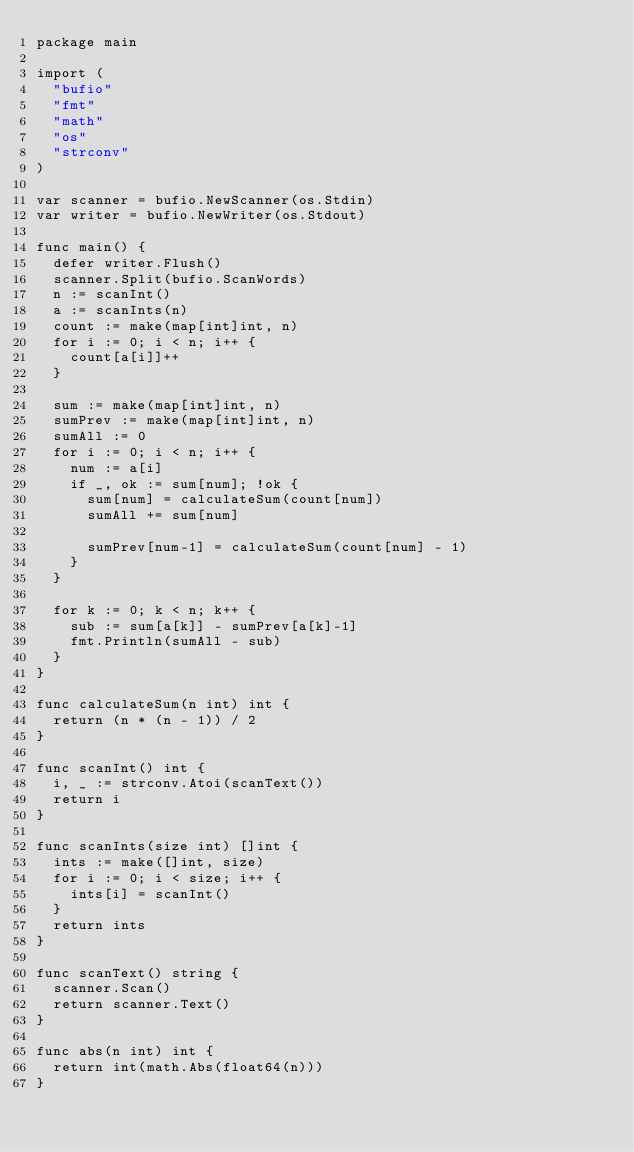<code> <loc_0><loc_0><loc_500><loc_500><_Go_>package main

import (
	"bufio"
	"fmt"
	"math"
	"os"
	"strconv"
)

var scanner = bufio.NewScanner(os.Stdin)
var writer = bufio.NewWriter(os.Stdout)

func main() {
	defer writer.Flush()
	scanner.Split(bufio.ScanWords)
	n := scanInt()
	a := scanInts(n)
	count := make(map[int]int, n)
	for i := 0; i < n; i++ {
		count[a[i]]++
	}

	sum := make(map[int]int, n)
	sumPrev := make(map[int]int, n)
	sumAll := 0
	for i := 0; i < n; i++ {
		num := a[i]
		if _, ok := sum[num]; !ok {
			sum[num] = calculateSum(count[num])
			sumAll += sum[num]

			sumPrev[num-1] = calculateSum(count[num] - 1)
		}
	}

	for k := 0; k < n; k++ {
		sub := sum[a[k]] - sumPrev[a[k]-1]
		fmt.Println(sumAll - sub)
	}
}

func calculateSum(n int) int {
	return (n * (n - 1)) / 2
}

func scanInt() int {
	i, _ := strconv.Atoi(scanText())
	return i
}

func scanInts(size int) []int {
	ints := make([]int, size)
	for i := 0; i < size; i++ {
		ints[i] = scanInt()
	}
	return ints
}

func scanText() string {
	scanner.Scan()
	return scanner.Text()
}

func abs(n int) int {
	return int(math.Abs(float64(n)))
}
</code> 